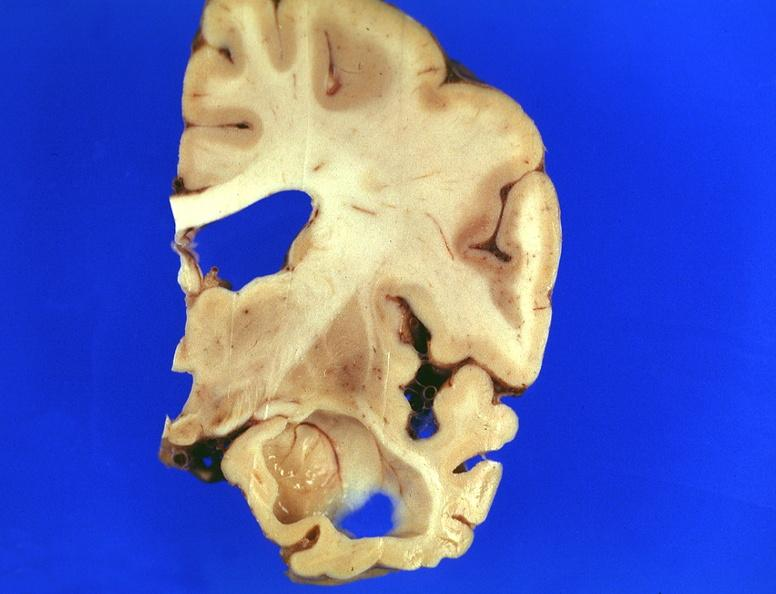does this image show brain, frontal lobe atrophy, pick 's disease?
Answer the question using a single word or phrase. Yes 